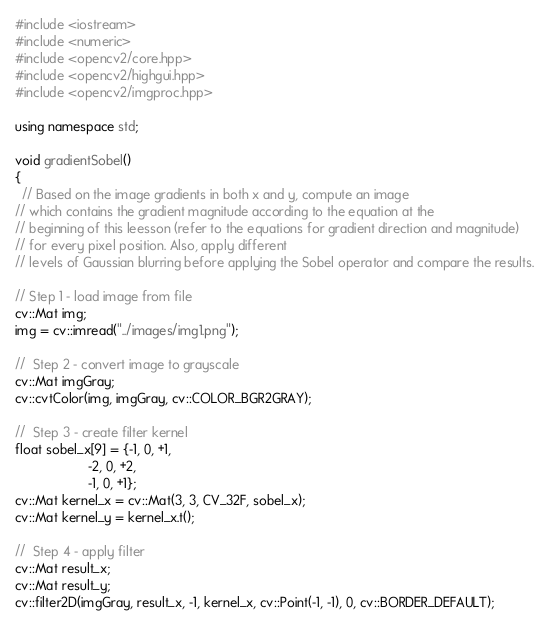<code> <loc_0><loc_0><loc_500><loc_500><_C++_>#include <iostream>
#include <numeric>
#include <opencv2/core.hpp>
#include <opencv2/highgui.hpp>
#include <opencv2/imgproc.hpp>

using namespace std;

void gradientSobel()
{
  // Based on the image gradients in both x and y, compute an image
// which contains the gradient magnitude according to the equation at the
// beginning of this leesson (refer to the equations for gradient direction and magnitude)
// for every pixel position. Also, apply different
// levels of Gaussian blurring before applying the Sobel operator and compare the results.

// Step 1 - load image from file
cv::Mat img;
img = cv::imread("../images/img1.png");

//  Step 2 - convert image to grayscale
cv::Mat imgGray;
cv::cvtColor(img, imgGray, cv::COLOR_BGR2GRAY);

//  Step 3 - create filter kernel
float sobel_x[9] = {-1, 0, +1,
                    -2, 0, +2,
                    -1, 0, +1};
cv::Mat kernel_x = cv::Mat(3, 3, CV_32F, sobel_x);
cv::Mat kernel_y = kernel_x.t();

//  Step 4 - apply filter
cv::Mat result_x;
cv::Mat result_y;
cv::filter2D(imgGray, result_x, -1, kernel_x, cv::Point(-1, -1), 0, cv::BORDER_DEFAULT);</code> 